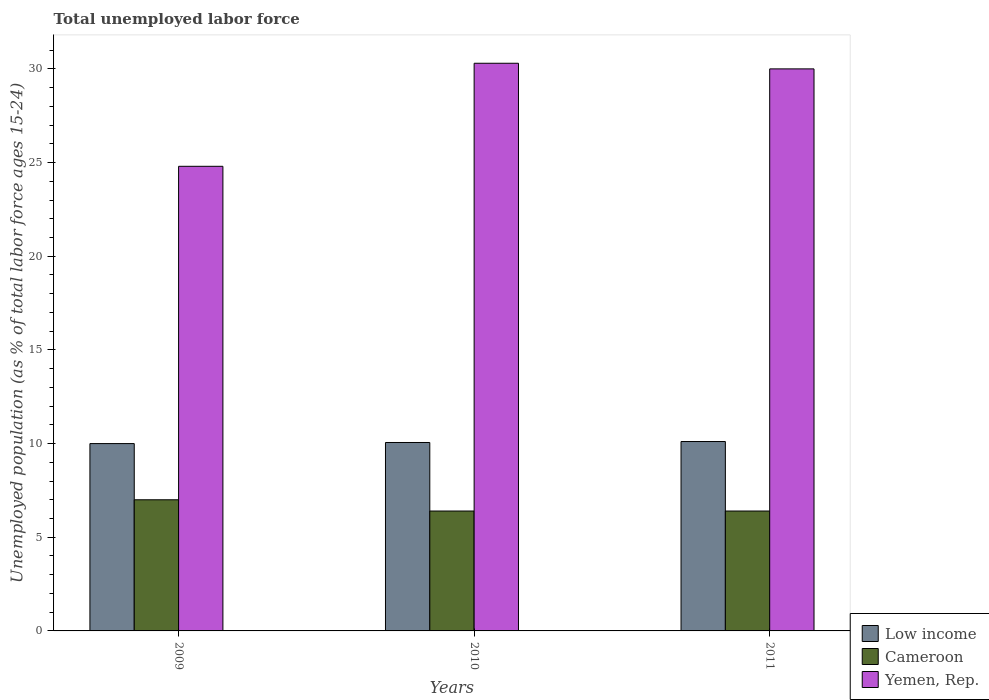How many groups of bars are there?
Keep it short and to the point. 3. Are the number of bars per tick equal to the number of legend labels?
Keep it short and to the point. Yes. Are the number of bars on each tick of the X-axis equal?
Make the answer very short. Yes. What is the label of the 3rd group of bars from the left?
Ensure brevity in your answer.  2011. In how many cases, is the number of bars for a given year not equal to the number of legend labels?
Provide a short and direct response. 0. What is the percentage of unemployed population in in Cameroon in 2010?
Your answer should be compact. 6.4. Across all years, what is the maximum percentage of unemployed population in in Yemen, Rep.?
Keep it short and to the point. 30.3. Across all years, what is the minimum percentage of unemployed population in in Low income?
Give a very brief answer. 10. In which year was the percentage of unemployed population in in Cameroon maximum?
Keep it short and to the point. 2009. What is the total percentage of unemployed population in in Yemen, Rep. in the graph?
Provide a short and direct response. 85.1. What is the difference between the percentage of unemployed population in in Cameroon in 2009 and that in 2011?
Ensure brevity in your answer.  0.6. What is the difference between the percentage of unemployed population in in Yemen, Rep. in 2011 and the percentage of unemployed population in in Low income in 2010?
Provide a succinct answer. 19.94. What is the average percentage of unemployed population in in Yemen, Rep. per year?
Offer a very short reply. 28.37. In the year 2010, what is the difference between the percentage of unemployed population in in Yemen, Rep. and percentage of unemployed population in in Low income?
Provide a short and direct response. 20.24. In how many years, is the percentage of unemployed population in in Low income greater than 5 %?
Your answer should be compact. 3. What is the ratio of the percentage of unemployed population in in Low income in 2009 to that in 2011?
Provide a succinct answer. 0.99. What is the difference between the highest and the second highest percentage of unemployed population in in Low income?
Your answer should be very brief. 0.05. What is the difference between the highest and the lowest percentage of unemployed population in in Yemen, Rep.?
Ensure brevity in your answer.  5.5. In how many years, is the percentage of unemployed population in in Yemen, Rep. greater than the average percentage of unemployed population in in Yemen, Rep. taken over all years?
Ensure brevity in your answer.  2. Is the sum of the percentage of unemployed population in in Low income in 2009 and 2011 greater than the maximum percentage of unemployed population in in Cameroon across all years?
Your answer should be very brief. Yes. What does the 3rd bar from the left in 2010 represents?
Your answer should be compact. Yemen, Rep. What does the 3rd bar from the right in 2009 represents?
Your answer should be very brief. Low income. How many bars are there?
Provide a succinct answer. 9. How many years are there in the graph?
Ensure brevity in your answer.  3. Does the graph contain grids?
Your response must be concise. No. How are the legend labels stacked?
Ensure brevity in your answer.  Vertical. What is the title of the graph?
Provide a short and direct response. Total unemployed labor force. What is the label or title of the Y-axis?
Your answer should be very brief. Unemployed population (as % of total labor force ages 15-24). What is the Unemployed population (as % of total labor force ages 15-24) of Low income in 2009?
Your response must be concise. 10. What is the Unemployed population (as % of total labor force ages 15-24) of Yemen, Rep. in 2009?
Your answer should be compact. 24.8. What is the Unemployed population (as % of total labor force ages 15-24) of Low income in 2010?
Keep it short and to the point. 10.06. What is the Unemployed population (as % of total labor force ages 15-24) in Cameroon in 2010?
Provide a succinct answer. 6.4. What is the Unemployed population (as % of total labor force ages 15-24) in Yemen, Rep. in 2010?
Offer a very short reply. 30.3. What is the Unemployed population (as % of total labor force ages 15-24) in Low income in 2011?
Keep it short and to the point. 10.11. What is the Unemployed population (as % of total labor force ages 15-24) of Cameroon in 2011?
Ensure brevity in your answer.  6.4. Across all years, what is the maximum Unemployed population (as % of total labor force ages 15-24) in Low income?
Make the answer very short. 10.11. Across all years, what is the maximum Unemployed population (as % of total labor force ages 15-24) in Cameroon?
Offer a terse response. 7. Across all years, what is the maximum Unemployed population (as % of total labor force ages 15-24) of Yemen, Rep.?
Keep it short and to the point. 30.3. Across all years, what is the minimum Unemployed population (as % of total labor force ages 15-24) of Low income?
Offer a very short reply. 10. Across all years, what is the minimum Unemployed population (as % of total labor force ages 15-24) of Cameroon?
Offer a terse response. 6.4. Across all years, what is the minimum Unemployed population (as % of total labor force ages 15-24) of Yemen, Rep.?
Your answer should be compact. 24.8. What is the total Unemployed population (as % of total labor force ages 15-24) of Low income in the graph?
Ensure brevity in your answer.  30.17. What is the total Unemployed population (as % of total labor force ages 15-24) of Cameroon in the graph?
Offer a very short reply. 19.8. What is the total Unemployed population (as % of total labor force ages 15-24) of Yemen, Rep. in the graph?
Make the answer very short. 85.1. What is the difference between the Unemployed population (as % of total labor force ages 15-24) in Low income in 2009 and that in 2010?
Offer a terse response. -0.06. What is the difference between the Unemployed population (as % of total labor force ages 15-24) in Low income in 2009 and that in 2011?
Keep it short and to the point. -0.11. What is the difference between the Unemployed population (as % of total labor force ages 15-24) of Cameroon in 2009 and that in 2011?
Your response must be concise. 0.6. What is the difference between the Unemployed population (as % of total labor force ages 15-24) in Low income in 2010 and that in 2011?
Ensure brevity in your answer.  -0.05. What is the difference between the Unemployed population (as % of total labor force ages 15-24) in Yemen, Rep. in 2010 and that in 2011?
Your answer should be compact. 0.3. What is the difference between the Unemployed population (as % of total labor force ages 15-24) in Low income in 2009 and the Unemployed population (as % of total labor force ages 15-24) in Cameroon in 2010?
Your answer should be very brief. 3.6. What is the difference between the Unemployed population (as % of total labor force ages 15-24) of Low income in 2009 and the Unemployed population (as % of total labor force ages 15-24) of Yemen, Rep. in 2010?
Your answer should be compact. -20.3. What is the difference between the Unemployed population (as % of total labor force ages 15-24) of Cameroon in 2009 and the Unemployed population (as % of total labor force ages 15-24) of Yemen, Rep. in 2010?
Your answer should be very brief. -23.3. What is the difference between the Unemployed population (as % of total labor force ages 15-24) of Low income in 2009 and the Unemployed population (as % of total labor force ages 15-24) of Cameroon in 2011?
Offer a very short reply. 3.6. What is the difference between the Unemployed population (as % of total labor force ages 15-24) of Low income in 2009 and the Unemployed population (as % of total labor force ages 15-24) of Yemen, Rep. in 2011?
Make the answer very short. -20. What is the difference between the Unemployed population (as % of total labor force ages 15-24) in Low income in 2010 and the Unemployed population (as % of total labor force ages 15-24) in Cameroon in 2011?
Give a very brief answer. 3.66. What is the difference between the Unemployed population (as % of total labor force ages 15-24) of Low income in 2010 and the Unemployed population (as % of total labor force ages 15-24) of Yemen, Rep. in 2011?
Provide a succinct answer. -19.94. What is the difference between the Unemployed population (as % of total labor force ages 15-24) of Cameroon in 2010 and the Unemployed population (as % of total labor force ages 15-24) of Yemen, Rep. in 2011?
Provide a short and direct response. -23.6. What is the average Unemployed population (as % of total labor force ages 15-24) of Low income per year?
Ensure brevity in your answer.  10.06. What is the average Unemployed population (as % of total labor force ages 15-24) in Cameroon per year?
Your answer should be very brief. 6.6. What is the average Unemployed population (as % of total labor force ages 15-24) of Yemen, Rep. per year?
Keep it short and to the point. 28.37. In the year 2009, what is the difference between the Unemployed population (as % of total labor force ages 15-24) in Low income and Unemployed population (as % of total labor force ages 15-24) in Cameroon?
Your answer should be very brief. 3. In the year 2009, what is the difference between the Unemployed population (as % of total labor force ages 15-24) in Low income and Unemployed population (as % of total labor force ages 15-24) in Yemen, Rep.?
Your answer should be compact. -14.8. In the year 2009, what is the difference between the Unemployed population (as % of total labor force ages 15-24) of Cameroon and Unemployed population (as % of total labor force ages 15-24) of Yemen, Rep.?
Provide a succinct answer. -17.8. In the year 2010, what is the difference between the Unemployed population (as % of total labor force ages 15-24) of Low income and Unemployed population (as % of total labor force ages 15-24) of Cameroon?
Provide a succinct answer. 3.66. In the year 2010, what is the difference between the Unemployed population (as % of total labor force ages 15-24) in Low income and Unemployed population (as % of total labor force ages 15-24) in Yemen, Rep.?
Your answer should be compact. -20.24. In the year 2010, what is the difference between the Unemployed population (as % of total labor force ages 15-24) in Cameroon and Unemployed population (as % of total labor force ages 15-24) in Yemen, Rep.?
Provide a short and direct response. -23.9. In the year 2011, what is the difference between the Unemployed population (as % of total labor force ages 15-24) of Low income and Unemployed population (as % of total labor force ages 15-24) of Cameroon?
Your response must be concise. 3.71. In the year 2011, what is the difference between the Unemployed population (as % of total labor force ages 15-24) of Low income and Unemployed population (as % of total labor force ages 15-24) of Yemen, Rep.?
Give a very brief answer. -19.89. In the year 2011, what is the difference between the Unemployed population (as % of total labor force ages 15-24) of Cameroon and Unemployed population (as % of total labor force ages 15-24) of Yemen, Rep.?
Keep it short and to the point. -23.6. What is the ratio of the Unemployed population (as % of total labor force ages 15-24) in Low income in 2009 to that in 2010?
Keep it short and to the point. 0.99. What is the ratio of the Unemployed population (as % of total labor force ages 15-24) in Cameroon in 2009 to that in 2010?
Your answer should be compact. 1.09. What is the ratio of the Unemployed population (as % of total labor force ages 15-24) of Yemen, Rep. in 2009 to that in 2010?
Keep it short and to the point. 0.82. What is the ratio of the Unemployed population (as % of total labor force ages 15-24) of Low income in 2009 to that in 2011?
Provide a succinct answer. 0.99. What is the ratio of the Unemployed population (as % of total labor force ages 15-24) of Cameroon in 2009 to that in 2011?
Provide a succinct answer. 1.09. What is the ratio of the Unemployed population (as % of total labor force ages 15-24) of Yemen, Rep. in 2009 to that in 2011?
Make the answer very short. 0.83. What is the difference between the highest and the second highest Unemployed population (as % of total labor force ages 15-24) in Low income?
Your answer should be compact. 0.05. What is the difference between the highest and the second highest Unemployed population (as % of total labor force ages 15-24) in Yemen, Rep.?
Ensure brevity in your answer.  0.3. What is the difference between the highest and the lowest Unemployed population (as % of total labor force ages 15-24) in Low income?
Offer a very short reply. 0.11. What is the difference between the highest and the lowest Unemployed population (as % of total labor force ages 15-24) in Cameroon?
Provide a succinct answer. 0.6. 